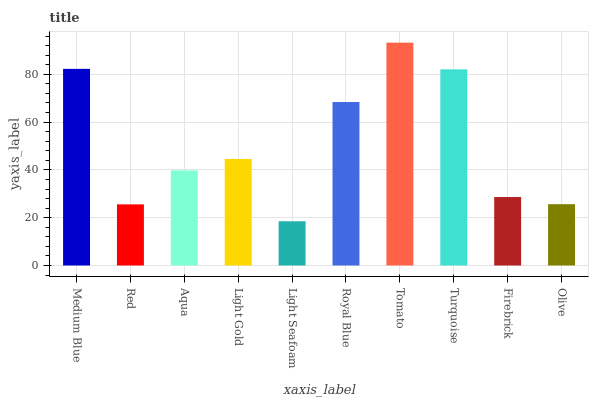Is Light Seafoam the minimum?
Answer yes or no. Yes. Is Tomato the maximum?
Answer yes or no. Yes. Is Red the minimum?
Answer yes or no. No. Is Red the maximum?
Answer yes or no. No. Is Medium Blue greater than Red?
Answer yes or no. Yes. Is Red less than Medium Blue?
Answer yes or no. Yes. Is Red greater than Medium Blue?
Answer yes or no. No. Is Medium Blue less than Red?
Answer yes or no. No. Is Light Gold the high median?
Answer yes or no. Yes. Is Aqua the low median?
Answer yes or no. Yes. Is Firebrick the high median?
Answer yes or no. No. Is Medium Blue the low median?
Answer yes or no. No. 